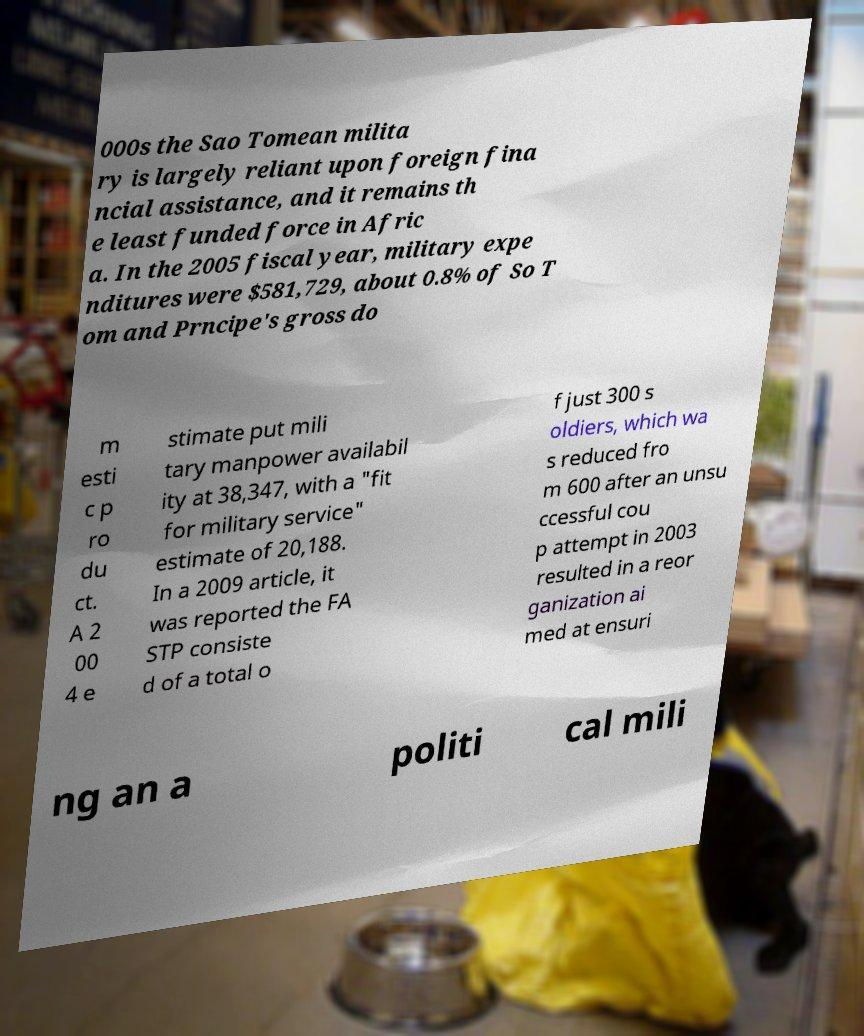Can you read and provide the text displayed in the image?This photo seems to have some interesting text. Can you extract and type it out for me? 000s the Sao Tomean milita ry is largely reliant upon foreign fina ncial assistance, and it remains th e least funded force in Afric a. In the 2005 fiscal year, military expe nditures were $581,729, about 0.8% of So T om and Prncipe's gross do m esti c p ro du ct. A 2 00 4 e stimate put mili tary manpower availabil ity at 38,347, with a "fit for military service" estimate of 20,188. In a 2009 article, it was reported the FA STP consiste d of a total o f just 300 s oldiers, which wa s reduced fro m 600 after an unsu ccessful cou p attempt in 2003 resulted in a reor ganization ai med at ensuri ng an a politi cal mili 